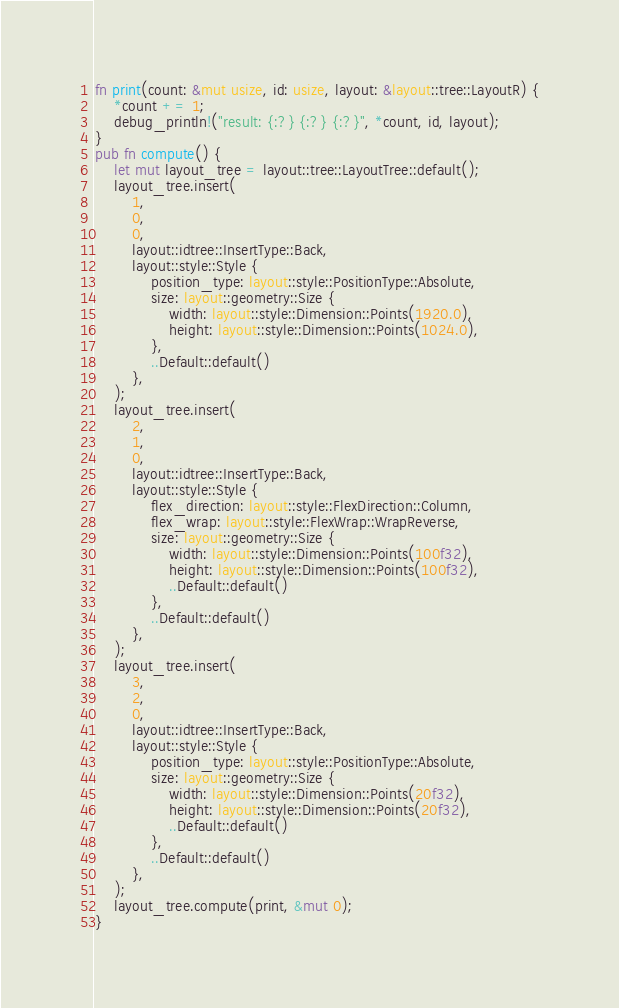<code> <loc_0><loc_0><loc_500><loc_500><_Rust_>fn print(count: &mut usize, id: usize, layout: &layout::tree::LayoutR) {
    *count += 1;
    debug_println!("result: {:?} {:?} {:?}", *count, id, layout);
}
pub fn compute() {
    let mut layout_tree = layout::tree::LayoutTree::default();
    layout_tree.insert(
        1,
        0,
        0,
        layout::idtree::InsertType::Back,
        layout::style::Style {
            position_type: layout::style::PositionType::Absolute,
            size: layout::geometry::Size {
                width: layout::style::Dimension::Points(1920.0),
                height: layout::style::Dimension::Points(1024.0),
            },
            ..Default::default()
        },
    );
    layout_tree.insert(
        2,
        1,
        0,
        layout::idtree::InsertType::Back,
        layout::style::Style {
            flex_direction: layout::style::FlexDirection::Column,
            flex_wrap: layout::style::FlexWrap::WrapReverse,
            size: layout::geometry::Size {
                width: layout::style::Dimension::Points(100f32),
                height: layout::style::Dimension::Points(100f32),
                ..Default::default()
            },
            ..Default::default()
        },
    );
    layout_tree.insert(
        3,
        2,
        0,
        layout::idtree::InsertType::Back,
        layout::style::Style {
            position_type: layout::style::PositionType::Absolute,
            size: layout::geometry::Size {
                width: layout::style::Dimension::Points(20f32),
                height: layout::style::Dimension::Points(20f32),
                ..Default::default()
            },
            ..Default::default()
        },
    );
    layout_tree.compute(print, &mut 0);
}
</code> 